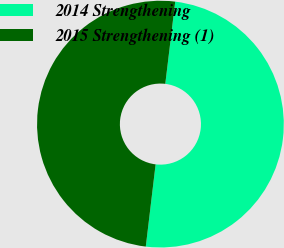<chart> <loc_0><loc_0><loc_500><loc_500><pie_chart><fcel>2014 Strengthening<fcel>2015 Strengthening (1)<nl><fcel>49.98%<fcel>50.02%<nl></chart> 